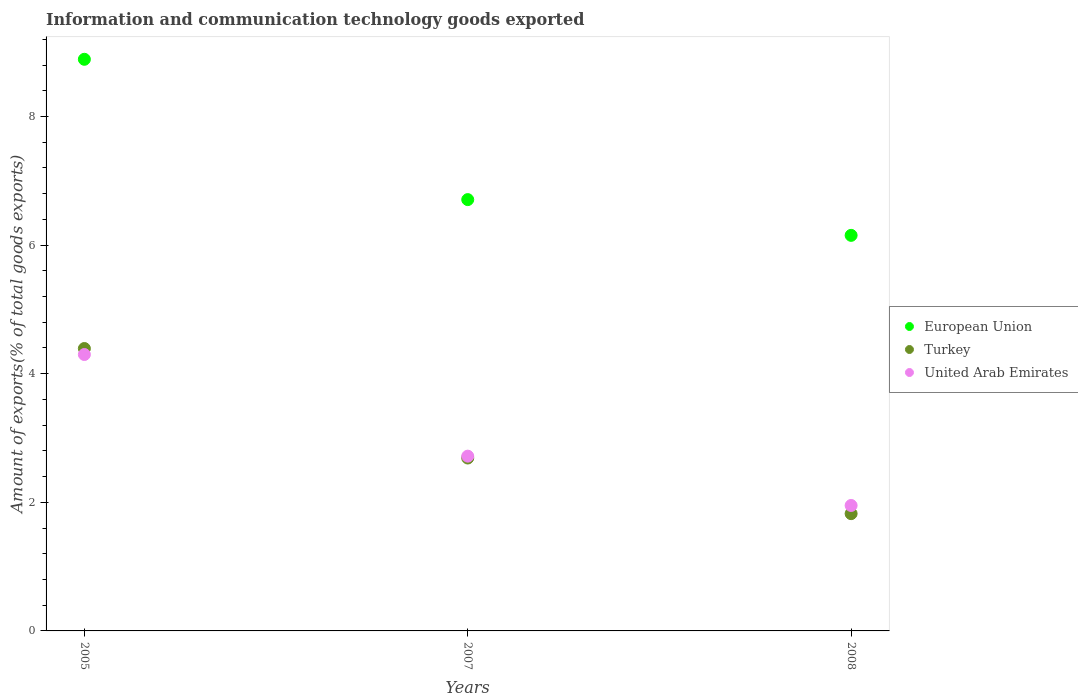What is the amount of goods exported in European Union in 2005?
Your response must be concise. 8.89. Across all years, what is the maximum amount of goods exported in Turkey?
Your answer should be very brief. 4.39. Across all years, what is the minimum amount of goods exported in United Arab Emirates?
Your answer should be very brief. 1.95. In which year was the amount of goods exported in United Arab Emirates maximum?
Give a very brief answer. 2005. What is the total amount of goods exported in Turkey in the graph?
Make the answer very short. 8.9. What is the difference between the amount of goods exported in United Arab Emirates in 2007 and that in 2008?
Offer a very short reply. 0.77. What is the difference between the amount of goods exported in United Arab Emirates in 2005 and the amount of goods exported in Turkey in 2008?
Your response must be concise. 2.47. What is the average amount of goods exported in Turkey per year?
Keep it short and to the point. 2.97. In the year 2007, what is the difference between the amount of goods exported in European Union and amount of goods exported in United Arab Emirates?
Make the answer very short. 3.99. In how many years, is the amount of goods exported in European Union greater than 2.4 %?
Keep it short and to the point. 3. What is the ratio of the amount of goods exported in United Arab Emirates in 2005 to that in 2008?
Offer a terse response. 2.2. Is the amount of goods exported in European Union in 2005 less than that in 2007?
Your answer should be very brief. No. What is the difference between the highest and the second highest amount of goods exported in Turkey?
Provide a short and direct response. 1.7. What is the difference between the highest and the lowest amount of goods exported in Turkey?
Offer a very short reply. 2.57. In how many years, is the amount of goods exported in United Arab Emirates greater than the average amount of goods exported in United Arab Emirates taken over all years?
Ensure brevity in your answer.  1. Is the sum of the amount of goods exported in Turkey in 2005 and 2007 greater than the maximum amount of goods exported in United Arab Emirates across all years?
Offer a very short reply. Yes. Is it the case that in every year, the sum of the amount of goods exported in United Arab Emirates and amount of goods exported in Turkey  is greater than the amount of goods exported in European Union?
Make the answer very short. No. Does the amount of goods exported in United Arab Emirates monotonically increase over the years?
Your answer should be very brief. No. How many dotlines are there?
Offer a terse response. 3. How many years are there in the graph?
Provide a short and direct response. 3. Does the graph contain any zero values?
Keep it short and to the point. No. How many legend labels are there?
Make the answer very short. 3. How are the legend labels stacked?
Provide a succinct answer. Vertical. What is the title of the graph?
Keep it short and to the point. Information and communication technology goods exported. What is the label or title of the X-axis?
Your answer should be very brief. Years. What is the label or title of the Y-axis?
Keep it short and to the point. Amount of exports(% of total goods exports). What is the Amount of exports(% of total goods exports) of European Union in 2005?
Ensure brevity in your answer.  8.89. What is the Amount of exports(% of total goods exports) in Turkey in 2005?
Your answer should be compact. 4.39. What is the Amount of exports(% of total goods exports) in United Arab Emirates in 2005?
Your answer should be compact. 4.3. What is the Amount of exports(% of total goods exports) of European Union in 2007?
Your answer should be very brief. 6.71. What is the Amount of exports(% of total goods exports) in Turkey in 2007?
Keep it short and to the point. 2.69. What is the Amount of exports(% of total goods exports) in United Arab Emirates in 2007?
Offer a very short reply. 2.72. What is the Amount of exports(% of total goods exports) of European Union in 2008?
Your answer should be compact. 6.15. What is the Amount of exports(% of total goods exports) of Turkey in 2008?
Give a very brief answer. 1.82. What is the Amount of exports(% of total goods exports) of United Arab Emirates in 2008?
Make the answer very short. 1.95. Across all years, what is the maximum Amount of exports(% of total goods exports) of European Union?
Your response must be concise. 8.89. Across all years, what is the maximum Amount of exports(% of total goods exports) of Turkey?
Offer a terse response. 4.39. Across all years, what is the maximum Amount of exports(% of total goods exports) of United Arab Emirates?
Give a very brief answer. 4.3. Across all years, what is the minimum Amount of exports(% of total goods exports) in European Union?
Your answer should be very brief. 6.15. Across all years, what is the minimum Amount of exports(% of total goods exports) in Turkey?
Make the answer very short. 1.82. Across all years, what is the minimum Amount of exports(% of total goods exports) in United Arab Emirates?
Make the answer very short. 1.95. What is the total Amount of exports(% of total goods exports) of European Union in the graph?
Offer a terse response. 21.75. What is the total Amount of exports(% of total goods exports) of Turkey in the graph?
Your response must be concise. 8.9. What is the total Amount of exports(% of total goods exports) of United Arab Emirates in the graph?
Your response must be concise. 8.97. What is the difference between the Amount of exports(% of total goods exports) in European Union in 2005 and that in 2007?
Make the answer very short. 2.18. What is the difference between the Amount of exports(% of total goods exports) in Turkey in 2005 and that in 2007?
Give a very brief answer. 1.7. What is the difference between the Amount of exports(% of total goods exports) in United Arab Emirates in 2005 and that in 2007?
Offer a terse response. 1.58. What is the difference between the Amount of exports(% of total goods exports) of European Union in 2005 and that in 2008?
Provide a short and direct response. 2.74. What is the difference between the Amount of exports(% of total goods exports) in Turkey in 2005 and that in 2008?
Your answer should be very brief. 2.57. What is the difference between the Amount of exports(% of total goods exports) in United Arab Emirates in 2005 and that in 2008?
Your answer should be compact. 2.35. What is the difference between the Amount of exports(% of total goods exports) in European Union in 2007 and that in 2008?
Provide a succinct answer. 0.56. What is the difference between the Amount of exports(% of total goods exports) in Turkey in 2007 and that in 2008?
Provide a succinct answer. 0.87. What is the difference between the Amount of exports(% of total goods exports) of United Arab Emirates in 2007 and that in 2008?
Ensure brevity in your answer.  0.77. What is the difference between the Amount of exports(% of total goods exports) in European Union in 2005 and the Amount of exports(% of total goods exports) in Turkey in 2007?
Your answer should be very brief. 6.2. What is the difference between the Amount of exports(% of total goods exports) of European Union in 2005 and the Amount of exports(% of total goods exports) of United Arab Emirates in 2007?
Provide a succinct answer. 6.17. What is the difference between the Amount of exports(% of total goods exports) of Turkey in 2005 and the Amount of exports(% of total goods exports) of United Arab Emirates in 2007?
Your answer should be compact. 1.67. What is the difference between the Amount of exports(% of total goods exports) of European Union in 2005 and the Amount of exports(% of total goods exports) of Turkey in 2008?
Your answer should be compact. 7.07. What is the difference between the Amount of exports(% of total goods exports) of European Union in 2005 and the Amount of exports(% of total goods exports) of United Arab Emirates in 2008?
Keep it short and to the point. 6.94. What is the difference between the Amount of exports(% of total goods exports) in Turkey in 2005 and the Amount of exports(% of total goods exports) in United Arab Emirates in 2008?
Give a very brief answer. 2.44. What is the difference between the Amount of exports(% of total goods exports) in European Union in 2007 and the Amount of exports(% of total goods exports) in Turkey in 2008?
Provide a succinct answer. 4.88. What is the difference between the Amount of exports(% of total goods exports) in European Union in 2007 and the Amount of exports(% of total goods exports) in United Arab Emirates in 2008?
Give a very brief answer. 4.76. What is the difference between the Amount of exports(% of total goods exports) of Turkey in 2007 and the Amount of exports(% of total goods exports) of United Arab Emirates in 2008?
Offer a terse response. 0.74. What is the average Amount of exports(% of total goods exports) of European Union per year?
Provide a succinct answer. 7.25. What is the average Amount of exports(% of total goods exports) of Turkey per year?
Your answer should be compact. 2.97. What is the average Amount of exports(% of total goods exports) of United Arab Emirates per year?
Provide a succinct answer. 2.99. In the year 2005, what is the difference between the Amount of exports(% of total goods exports) in European Union and Amount of exports(% of total goods exports) in Turkey?
Offer a very short reply. 4.5. In the year 2005, what is the difference between the Amount of exports(% of total goods exports) of European Union and Amount of exports(% of total goods exports) of United Arab Emirates?
Offer a very short reply. 4.59. In the year 2005, what is the difference between the Amount of exports(% of total goods exports) of Turkey and Amount of exports(% of total goods exports) of United Arab Emirates?
Ensure brevity in your answer.  0.09. In the year 2007, what is the difference between the Amount of exports(% of total goods exports) in European Union and Amount of exports(% of total goods exports) in Turkey?
Provide a short and direct response. 4.02. In the year 2007, what is the difference between the Amount of exports(% of total goods exports) in European Union and Amount of exports(% of total goods exports) in United Arab Emirates?
Ensure brevity in your answer.  3.99. In the year 2007, what is the difference between the Amount of exports(% of total goods exports) in Turkey and Amount of exports(% of total goods exports) in United Arab Emirates?
Provide a succinct answer. -0.03. In the year 2008, what is the difference between the Amount of exports(% of total goods exports) in European Union and Amount of exports(% of total goods exports) in Turkey?
Your answer should be compact. 4.33. In the year 2008, what is the difference between the Amount of exports(% of total goods exports) of European Union and Amount of exports(% of total goods exports) of United Arab Emirates?
Offer a very short reply. 4.2. In the year 2008, what is the difference between the Amount of exports(% of total goods exports) of Turkey and Amount of exports(% of total goods exports) of United Arab Emirates?
Your answer should be very brief. -0.13. What is the ratio of the Amount of exports(% of total goods exports) of European Union in 2005 to that in 2007?
Keep it short and to the point. 1.33. What is the ratio of the Amount of exports(% of total goods exports) in Turkey in 2005 to that in 2007?
Give a very brief answer. 1.63. What is the ratio of the Amount of exports(% of total goods exports) in United Arab Emirates in 2005 to that in 2007?
Keep it short and to the point. 1.58. What is the ratio of the Amount of exports(% of total goods exports) of European Union in 2005 to that in 2008?
Your response must be concise. 1.45. What is the ratio of the Amount of exports(% of total goods exports) in Turkey in 2005 to that in 2008?
Provide a succinct answer. 2.41. What is the ratio of the Amount of exports(% of total goods exports) in United Arab Emirates in 2005 to that in 2008?
Make the answer very short. 2.2. What is the ratio of the Amount of exports(% of total goods exports) of European Union in 2007 to that in 2008?
Give a very brief answer. 1.09. What is the ratio of the Amount of exports(% of total goods exports) of Turkey in 2007 to that in 2008?
Keep it short and to the point. 1.47. What is the ratio of the Amount of exports(% of total goods exports) of United Arab Emirates in 2007 to that in 2008?
Offer a very short reply. 1.39. What is the difference between the highest and the second highest Amount of exports(% of total goods exports) of European Union?
Your response must be concise. 2.18. What is the difference between the highest and the second highest Amount of exports(% of total goods exports) of Turkey?
Your answer should be very brief. 1.7. What is the difference between the highest and the second highest Amount of exports(% of total goods exports) of United Arab Emirates?
Offer a terse response. 1.58. What is the difference between the highest and the lowest Amount of exports(% of total goods exports) of European Union?
Your answer should be compact. 2.74. What is the difference between the highest and the lowest Amount of exports(% of total goods exports) in Turkey?
Your response must be concise. 2.57. What is the difference between the highest and the lowest Amount of exports(% of total goods exports) of United Arab Emirates?
Give a very brief answer. 2.35. 